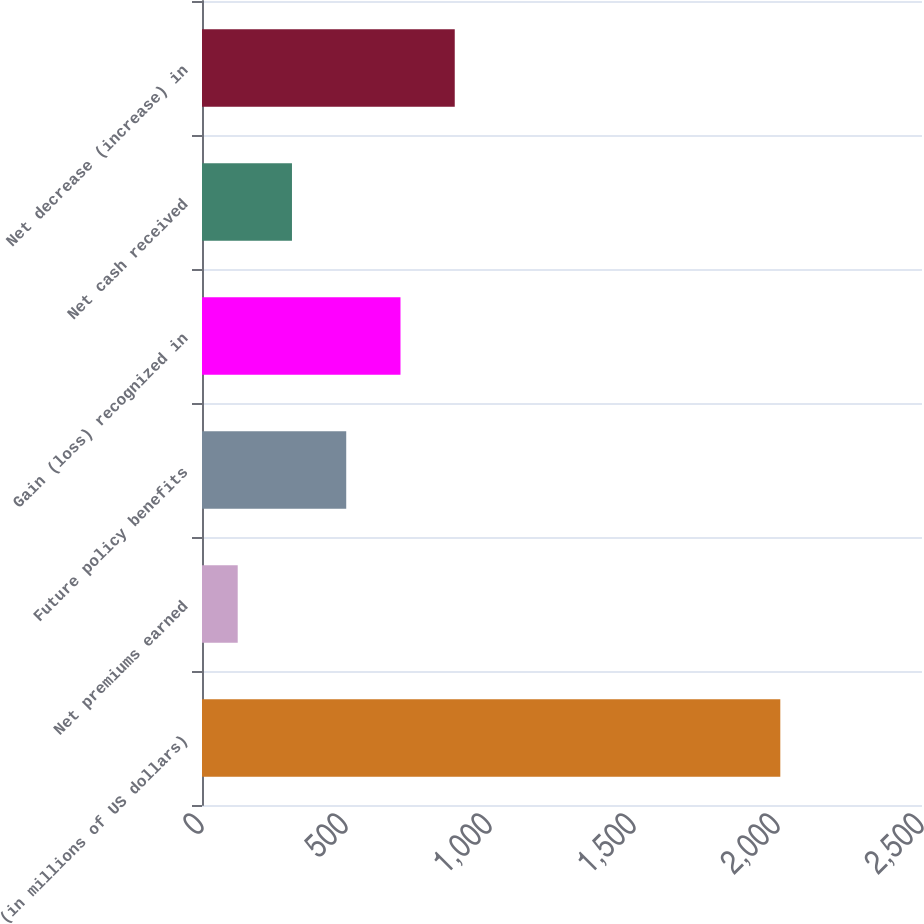Convert chart. <chart><loc_0><loc_0><loc_500><loc_500><bar_chart><fcel>(in millions of US dollars)<fcel>Net premiums earned<fcel>Future policy benefits<fcel>Gain (loss) recognized in<fcel>Net cash received<fcel>Net decrease (increase) in<nl><fcel>2008<fcel>124<fcel>500.8<fcel>689.2<fcel>312.4<fcel>877.6<nl></chart> 